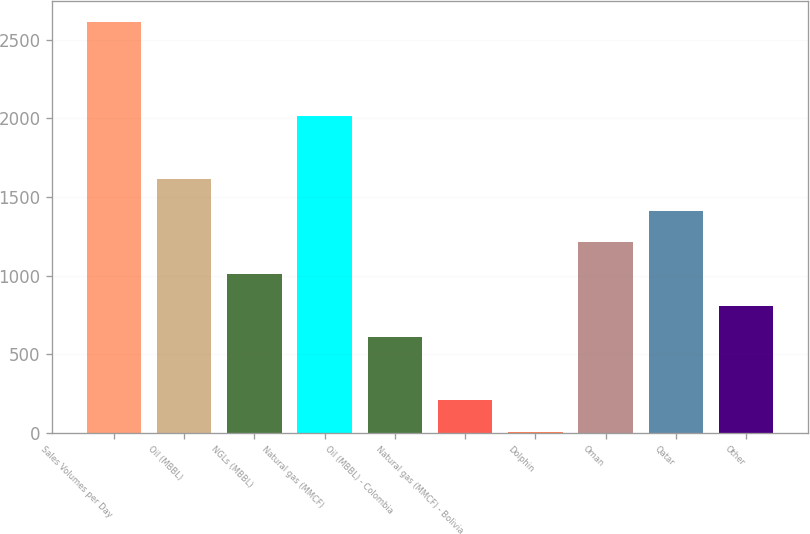Convert chart. <chart><loc_0><loc_0><loc_500><loc_500><bar_chart><fcel>Sales Volumes per Day<fcel>Oil (MBBL)<fcel>NGLs (MBBL)<fcel>Natural gas (MMCF)<fcel>Oil (MBBL) - Colombia<fcel>Natural gas (MMCF) - Bolivia<fcel>Dolphin<fcel>Oman<fcel>Qatar<fcel>Other<nl><fcel>2613.2<fcel>1611.2<fcel>1010<fcel>2012<fcel>609.2<fcel>208.4<fcel>8<fcel>1210.4<fcel>1410.8<fcel>809.6<nl></chart> 